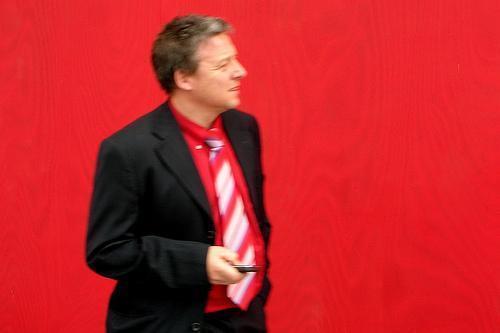How many hands are visible?
Give a very brief answer. 1. 